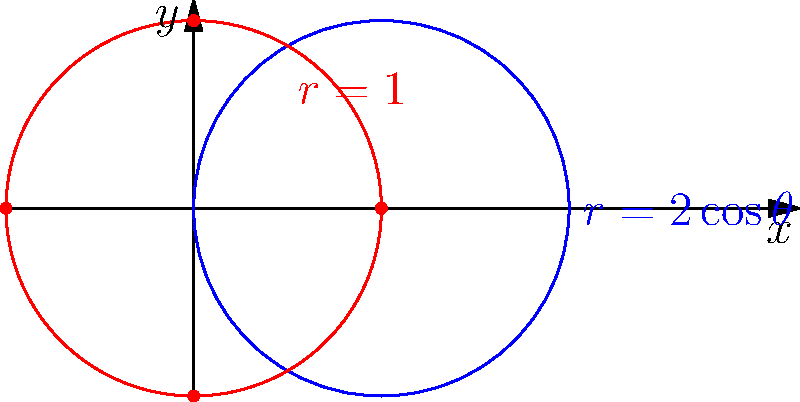Consider the polar curves $r_1 = 2\cos\theta$ and $r_2 = 1$. Determine the number of intersection points between these two curves and provide their coordinates in both polar and Cartesian forms. Let's approach this step-by-step:

1) To find the intersection points, we need to solve the equation:
   $2\cos\theta = 1$

2) Solving for $\theta$:
   $\cos\theta = \frac{1}{2}$
   $\theta = \pm \frac{\pi}{3}$ (in the interval $[0, 2\pi]$)

3) This gives us two intersection points in polar coordinates:
   $(\frac{\pi}{3}, 1)$ and $(-\frac{\pi}{3}, 1)$ or $(5\frac{\pi}{3}, 1)$

4) To convert to Cartesian coordinates, we use:
   $x = r\cos\theta$
   $y = r\sin\theta$

5) For $(\frac{\pi}{3}, 1)$:
   $x = \cos(\frac{\pi}{3}) = \frac{1}{2}$
   $y = \sin(\frac{\pi}{3}) = \frac{\sqrt{3}}{2}$

6) For $(-\frac{\pi}{3}, 1)$ or $(5\frac{\pi}{3}, 1)$:
   $x = \cos(-\frac{\pi}{3}) = \frac{1}{2}$
   $y = \sin(-\frac{\pi}{3}) = -\frac{\sqrt{3}}{2}$

Therefore, the two intersection points are:
- In polar coordinates: $(\frac{\pi}{3}, 1)$ and $(-\frac{\pi}{3}, 1)$
- In Cartesian coordinates: $(\frac{1}{2}, \frac{\sqrt{3}}{2})$ and $(\frac{1}{2}, -\frac{\sqrt{3}}{2})$
Answer: 2 points: $(\frac{\pi}{3}, 1)$ and $(-\frac{\pi}{3}, 1)$ in polar; $(\frac{1}{2}, \frac{\sqrt{3}}{2})$ and $(\frac{1}{2}, -\frac{\sqrt{3}}{2})$ in Cartesian. 